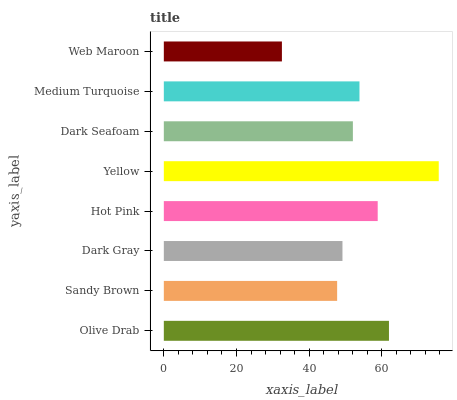Is Web Maroon the minimum?
Answer yes or no. Yes. Is Yellow the maximum?
Answer yes or no. Yes. Is Sandy Brown the minimum?
Answer yes or no. No. Is Sandy Brown the maximum?
Answer yes or no. No. Is Olive Drab greater than Sandy Brown?
Answer yes or no. Yes. Is Sandy Brown less than Olive Drab?
Answer yes or no. Yes. Is Sandy Brown greater than Olive Drab?
Answer yes or no. No. Is Olive Drab less than Sandy Brown?
Answer yes or no. No. Is Medium Turquoise the high median?
Answer yes or no. Yes. Is Dark Seafoam the low median?
Answer yes or no. Yes. Is Dark Seafoam the high median?
Answer yes or no. No. Is Yellow the low median?
Answer yes or no. No. 